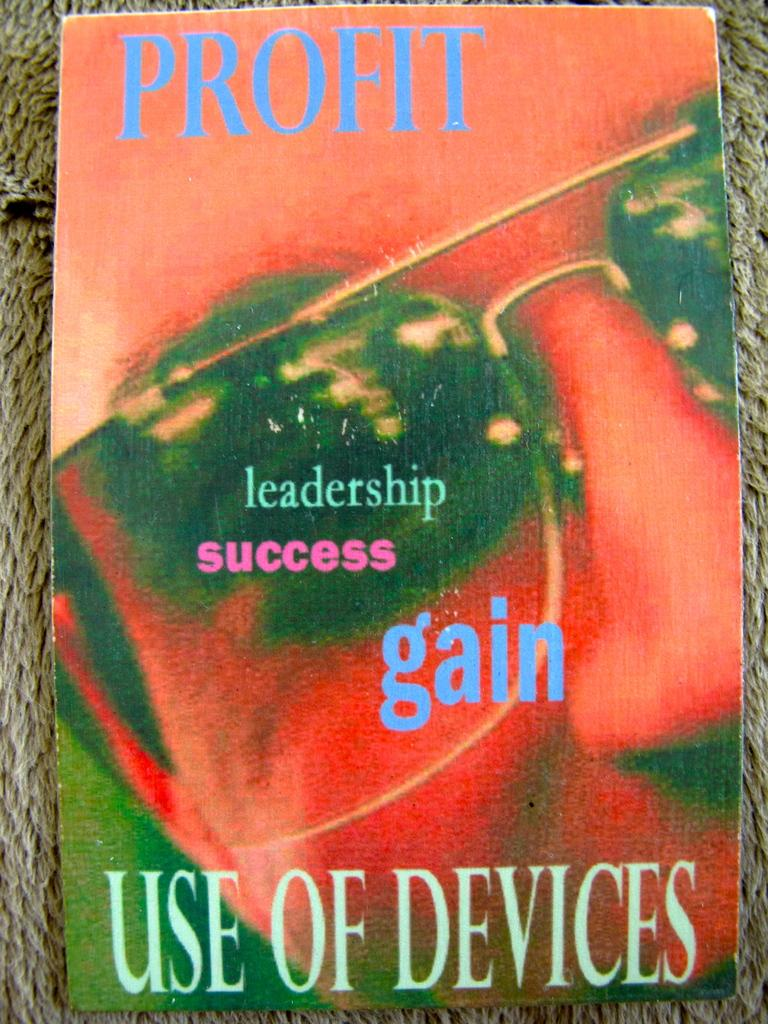<image>
Summarize the visual content of the image. A poster that touts profit, leadership success, gain and use of devises 